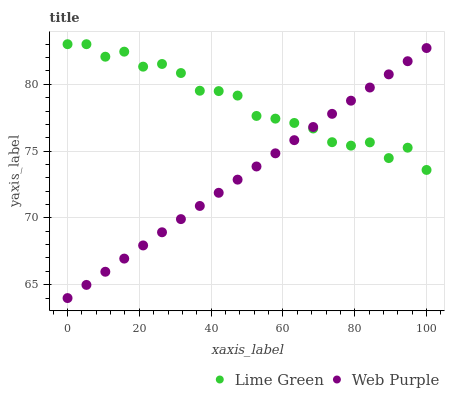Does Web Purple have the minimum area under the curve?
Answer yes or no. Yes. Does Lime Green have the maximum area under the curve?
Answer yes or no. Yes. Does Lime Green have the minimum area under the curve?
Answer yes or no. No. Is Web Purple the smoothest?
Answer yes or no. Yes. Is Lime Green the roughest?
Answer yes or no. Yes. Is Lime Green the smoothest?
Answer yes or no. No. Does Web Purple have the lowest value?
Answer yes or no. Yes. Does Lime Green have the lowest value?
Answer yes or no. No. Does Lime Green have the highest value?
Answer yes or no. Yes. Does Lime Green intersect Web Purple?
Answer yes or no. Yes. Is Lime Green less than Web Purple?
Answer yes or no. No. Is Lime Green greater than Web Purple?
Answer yes or no. No. 